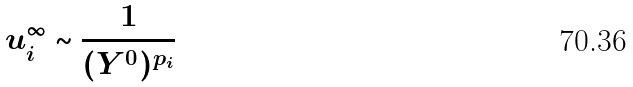<formula> <loc_0><loc_0><loc_500><loc_500>u _ { i } ^ { \infty } \sim \frac { 1 } { ( Y ^ { 0 } ) ^ { p _ { i } } }</formula> 